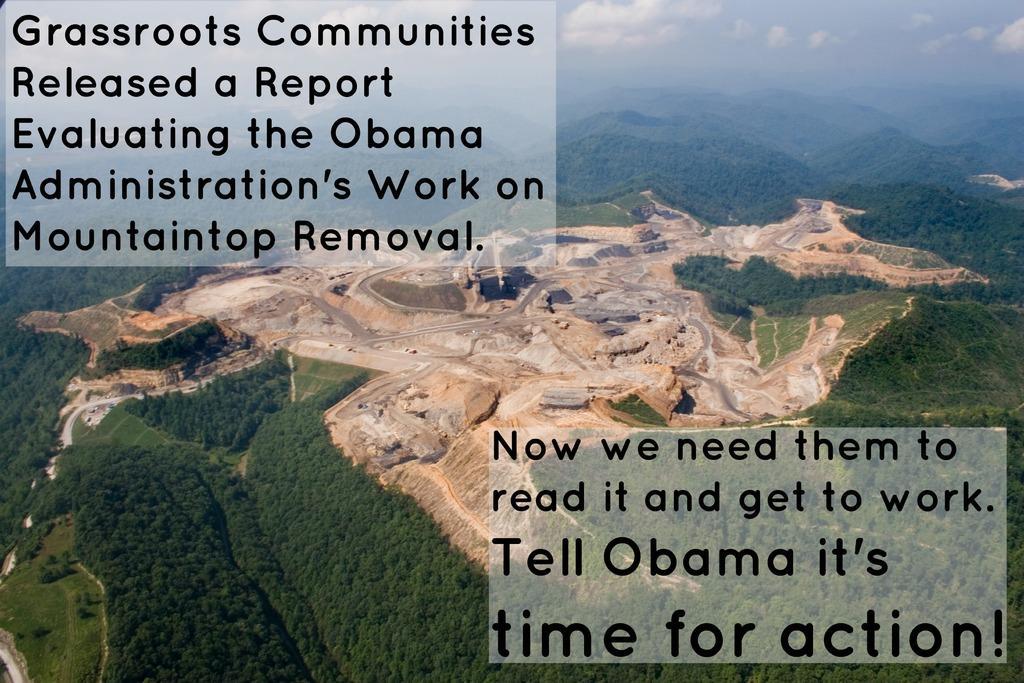Describe this image in one or two sentences. These are the hills with stones and green trees. There is a text in this image. 